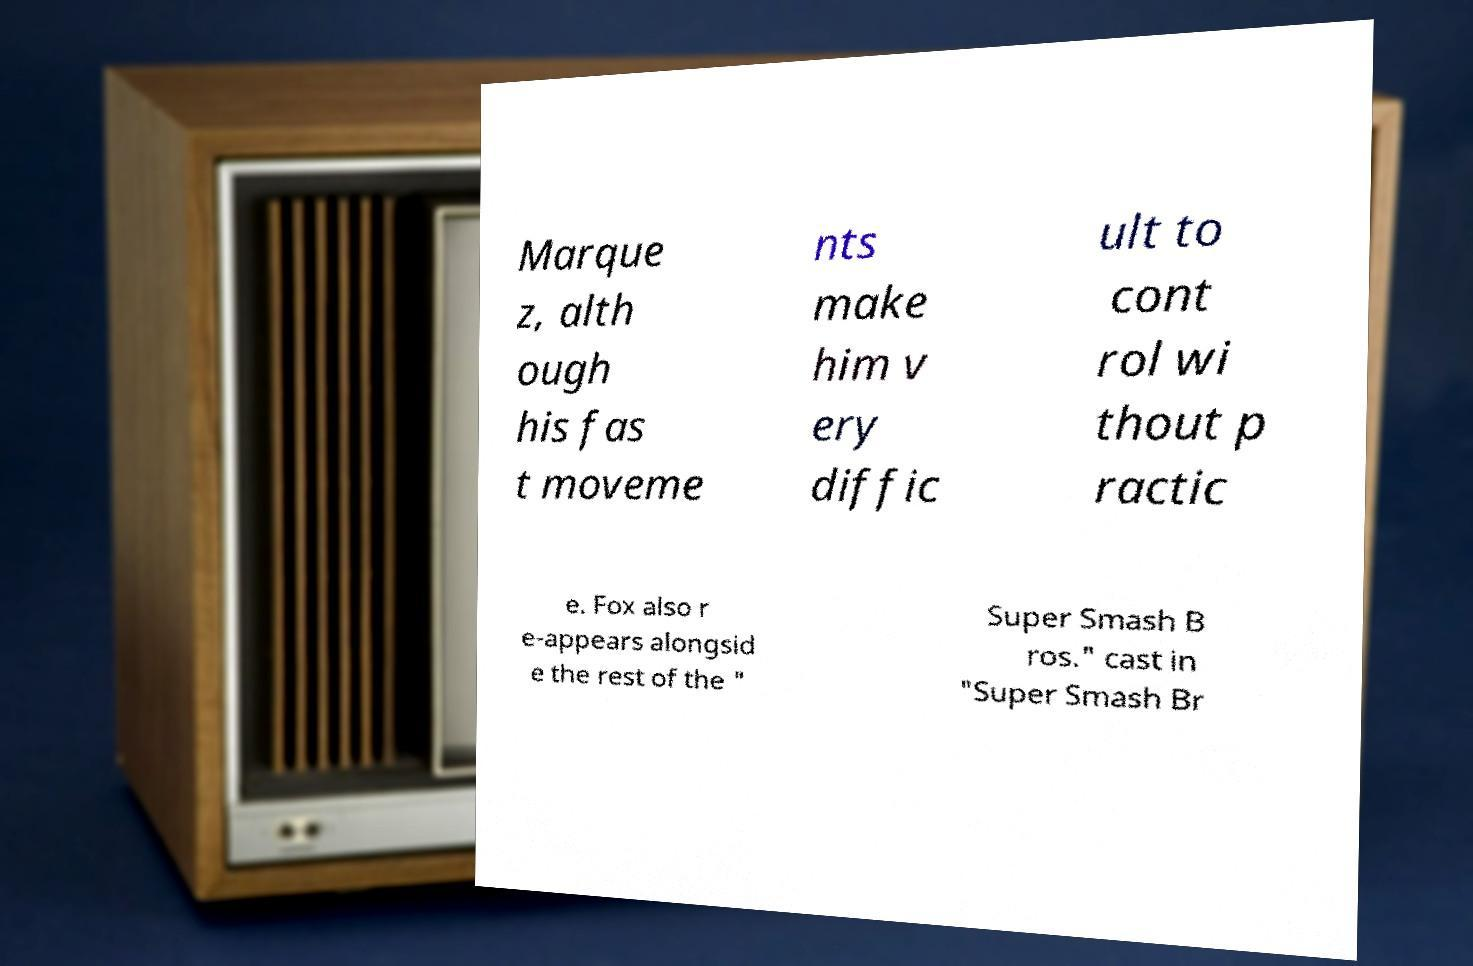For documentation purposes, I need the text within this image transcribed. Could you provide that? Marque z, alth ough his fas t moveme nts make him v ery diffic ult to cont rol wi thout p ractic e. Fox also r e-appears alongsid e the rest of the " Super Smash B ros." cast in "Super Smash Br 